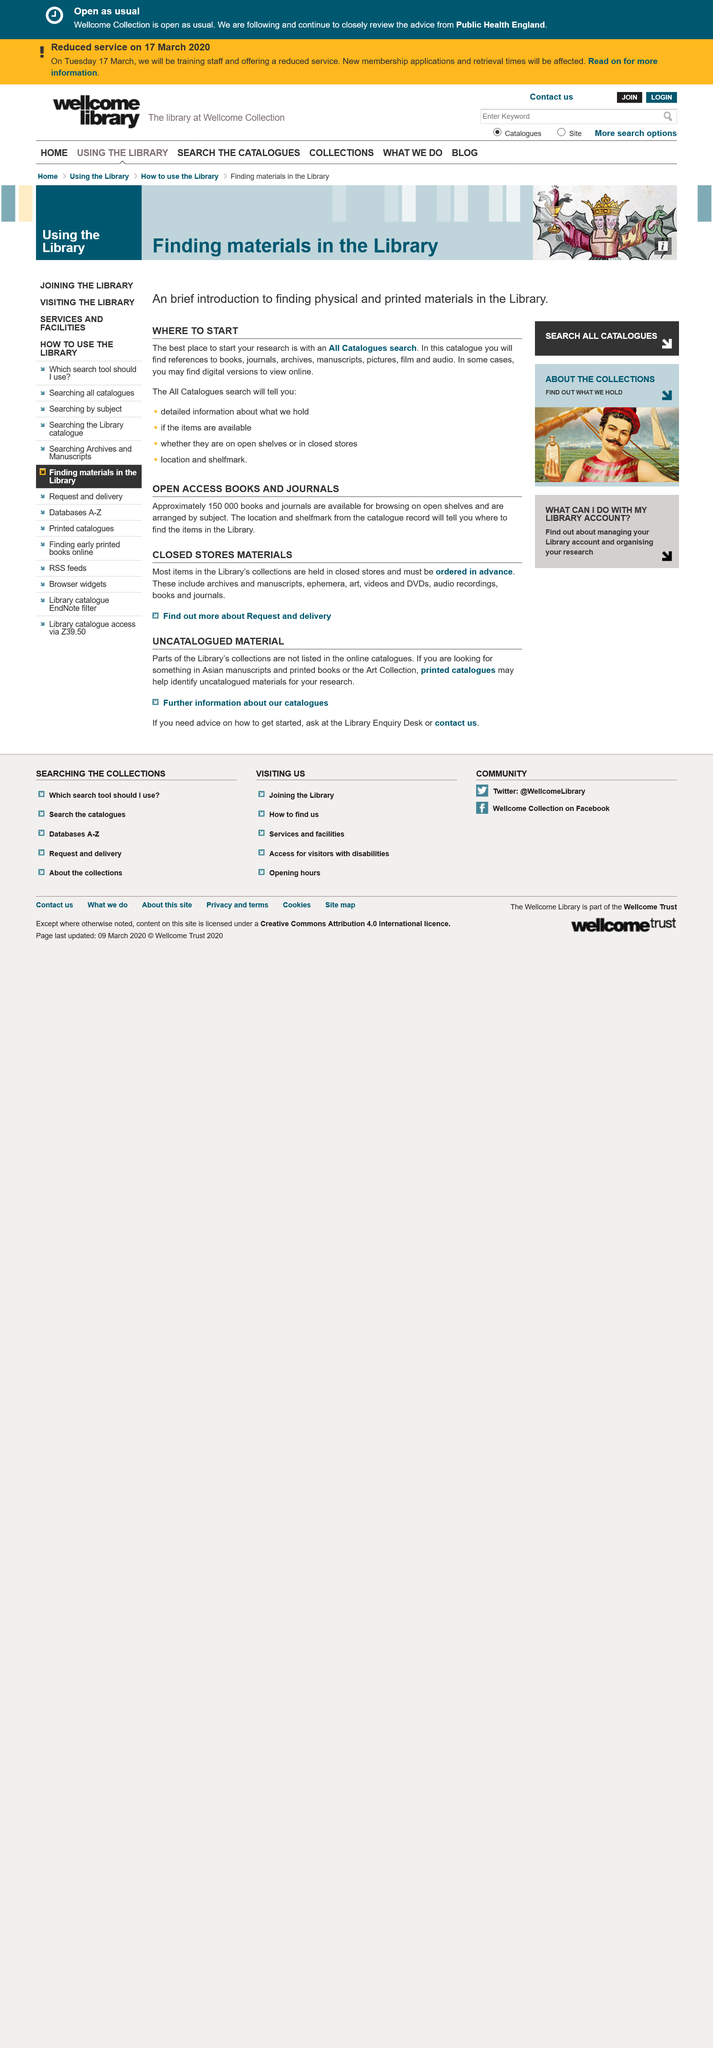List a handful of essential elements in this visual. Approximately 150,000 books and journals are available for browsing on open shelves. It is necessary to order closed store materials in advance. When seeking materials in Asian manuscripts, you would utilize printed catalogues. 